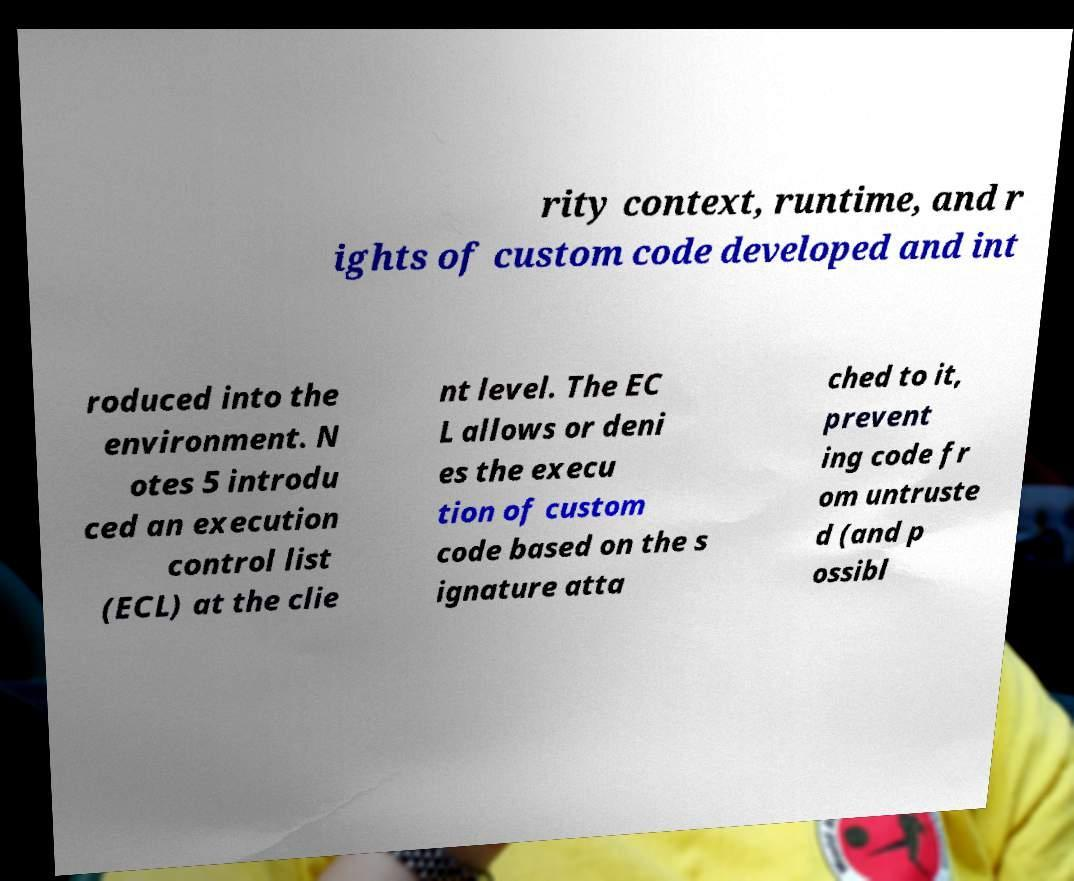Can you accurately transcribe the text from the provided image for me? rity context, runtime, and r ights of custom code developed and int roduced into the environment. N otes 5 introdu ced an execution control list (ECL) at the clie nt level. The EC L allows or deni es the execu tion of custom code based on the s ignature atta ched to it, prevent ing code fr om untruste d (and p ossibl 